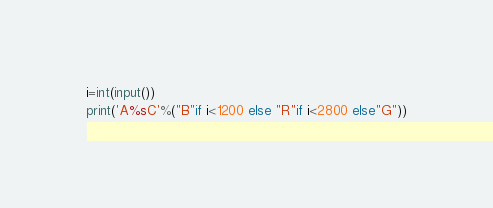<code> <loc_0><loc_0><loc_500><loc_500><_Python_>i=int(input())
print('A%sC'%("B"if i<1200 else "R"if i<2800 else"G"))</code> 